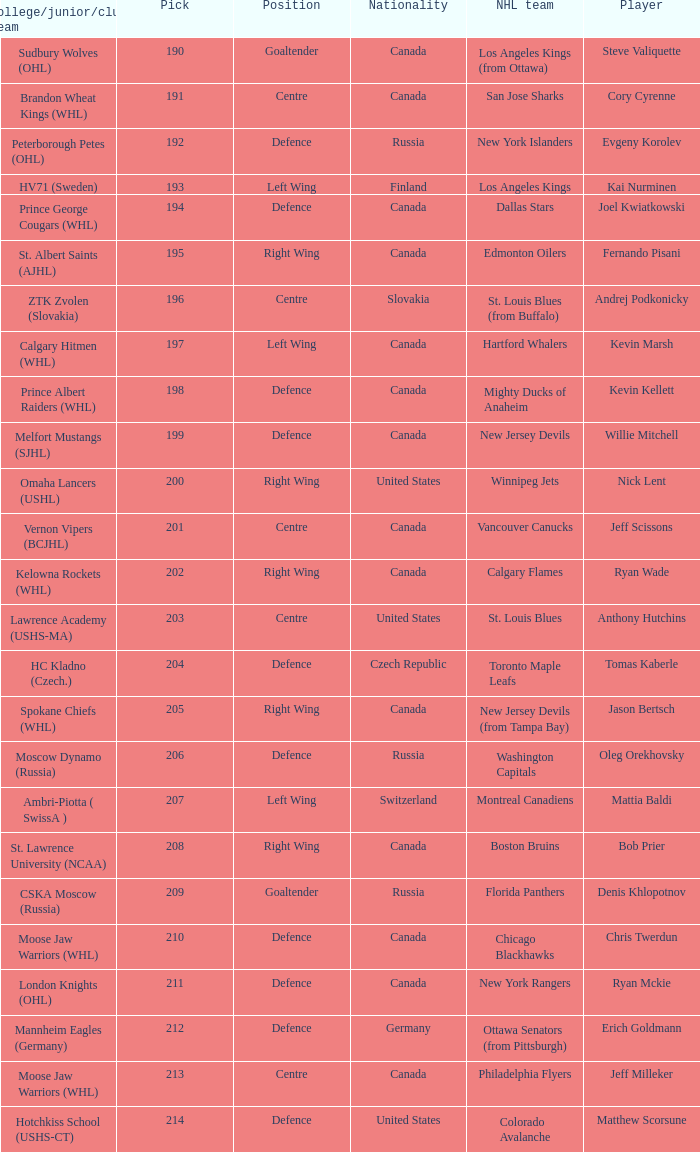Name the pick for matthew scorsune 214.0. Parse the full table. {'header': ['College/junior/club team', 'Pick', 'Position', 'Nationality', 'NHL team', 'Player'], 'rows': [['Sudbury Wolves (OHL)', '190', 'Goaltender', 'Canada', 'Los Angeles Kings (from Ottawa)', 'Steve Valiquette'], ['Brandon Wheat Kings (WHL)', '191', 'Centre', 'Canada', 'San Jose Sharks', 'Cory Cyrenne'], ['Peterborough Petes (OHL)', '192', 'Defence', 'Russia', 'New York Islanders', 'Evgeny Korolev'], ['HV71 (Sweden)', '193', 'Left Wing', 'Finland', 'Los Angeles Kings', 'Kai Nurminen'], ['Prince George Cougars (WHL)', '194', 'Defence', 'Canada', 'Dallas Stars', 'Joel Kwiatkowski'], ['St. Albert Saints (AJHL)', '195', 'Right Wing', 'Canada', 'Edmonton Oilers', 'Fernando Pisani'], ['ZTK Zvolen (Slovakia)', '196', 'Centre', 'Slovakia', 'St. Louis Blues (from Buffalo)', 'Andrej Podkonicky'], ['Calgary Hitmen (WHL)', '197', 'Left Wing', 'Canada', 'Hartford Whalers', 'Kevin Marsh'], ['Prince Albert Raiders (WHL)', '198', 'Defence', 'Canada', 'Mighty Ducks of Anaheim', 'Kevin Kellett'], ['Melfort Mustangs (SJHL)', '199', 'Defence', 'Canada', 'New Jersey Devils', 'Willie Mitchell'], ['Omaha Lancers (USHL)', '200', 'Right Wing', 'United States', 'Winnipeg Jets', 'Nick Lent'], ['Vernon Vipers (BCJHL)', '201', 'Centre', 'Canada', 'Vancouver Canucks', 'Jeff Scissons'], ['Kelowna Rockets (WHL)', '202', 'Right Wing', 'Canada', 'Calgary Flames', 'Ryan Wade'], ['Lawrence Academy (USHS-MA)', '203', 'Centre', 'United States', 'St. Louis Blues', 'Anthony Hutchins'], ['HC Kladno (Czech.)', '204', 'Defence', 'Czech Republic', 'Toronto Maple Leafs', 'Tomas Kaberle'], ['Spokane Chiefs (WHL)', '205', 'Right Wing', 'Canada', 'New Jersey Devils (from Tampa Bay)', 'Jason Bertsch'], ['Moscow Dynamo (Russia)', '206', 'Defence', 'Russia', 'Washington Capitals', 'Oleg Orekhovsky'], ['Ambri-Piotta ( SwissA )', '207', 'Left Wing', 'Switzerland', 'Montreal Canadiens', 'Mattia Baldi'], ['St. Lawrence University (NCAA)', '208', 'Right Wing', 'Canada', 'Boston Bruins', 'Bob Prier'], ['CSKA Moscow (Russia)', '209', 'Goaltender', 'Russia', 'Florida Panthers', 'Denis Khlopotnov'], ['Moose Jaw Warriors (WHL)', '210', 'Defence', 'Canada', 'Chicago Blackhawks', 'Chris Twerdun'], ['London Knights (OHL)', '211', 'Defence', 'Canada', 'New York Rangers', 'Ryan Mckie'], ['Mannheim Eagles (Germany)', '212', 'Defence', 'Germany', 'Ottawa Senators (from Pittsburgh)', 'Erich Goldmann'], ['Moose Jaw Warriors (WHL)', '213', 'Centre', 'Canada', 'Philadelphia Flyers', 'Jeff Milleker'], ['Hotchkiss School (USHS-CT)', '214', 'Defence', 'United States', 'Colorado Avalanche', 'Matthew Scorsune']]} 